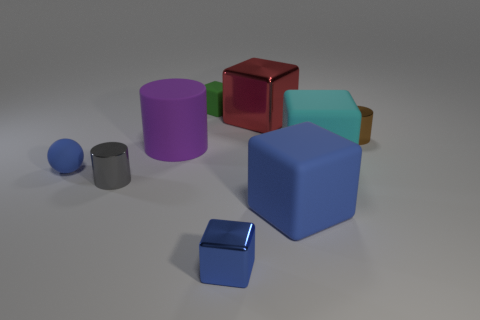Subtract all green cubes. How many cubes are left? 4 Subtract all red blocks. How many blocks are left? 4 Subtract all purple blocks. Subtract all brown balls. How many blocks are left? 5 Subtract all spheres. How many objects are left? 8 Subtract all rubber objects. Subtract all large red blocks. How many objects are left? 3 Add 6 big blocks. How many big blocks are left? 9 Add 9 big red cubes. How many big red cubes exist? 10 Subtract 1 gray cylinders. How many objects are left? 8 